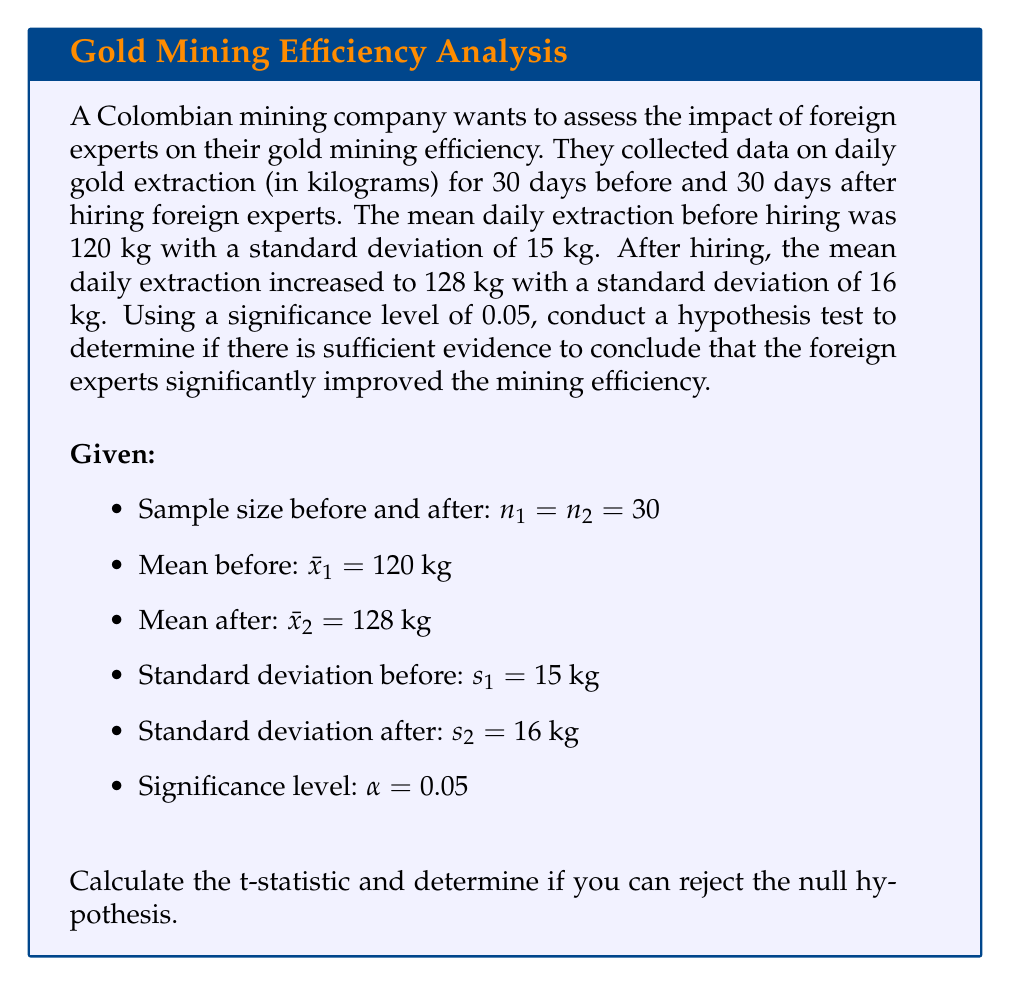Can you answer this question? To solve this problem, we'll use a two-sample t-test for independent samples with unequal variances (Welch's t-test). We'll follow these steps:

1. State the hypotheses:
   $H_0: \mu_1 = \mu_2$ (null hypothesis: no difference in means)
   $H_a: \mu_1 < \mu_2$ (alternative hypothesis: mean after is greater than mean before)

2. Calculate the degrees of freedom using the Welch–Satterthwaite equation:

   $$\nu = \frac{(\frac{s_1^2}{n_1} + \frac{s_2^2}{n_2})^2}{\frac{(s_1^2/n_1)^2}{n_1-1} + \frac{(s_2^2/n_2)^2}{n_2-1}}$$

   $$\nu = \frac{(\frac{15^2}{30} + \frac{16^2}{30})^2}{\frac{(15^2/30)^2}{29} + \frac{(16^2/30)^2}{29}} \approx 57.67$$

3. Calculate the t-statistic:

   $$t = \frac{\bar{x}_2 - \bar{x}_1}{\sqrt{\frac{s_1^2}{n_1} + \frac{s_2^2}{n_2}}}$$

   $$t = \frac{128 - 120}{\sqrt{\frac{15^2}{30} + \frac{16^2}{30}}} \approx 2.048$$

4. Find the critical t-value for a one-tailed test with $\alpha = 0.05$ and $\nu = 57.67$ (rounded to 57):
   $t_{\text{critical}} \approx 1.672$

5. Compare the calculated t-statistic to the critical t-value:
   Since $2.048 > 1.672$, we reject the null hypothesis.

6. Calculate the p-value:
   Using a t-distribution calculator with 57 degrees of freedom and t-statistic of 2.048, we get:
   $p\text{-value} \approx 0.0226$

   Since $p\text{-value} < \alpha$ (0.0226 < 0.05), we reject the null hypothesis.

Conclusion: There is sufficient evidence to conclude that the foreign experts significantly improved the mining efficiency at the 0.05 significance level.
Answer: Reject the null hypothesis. The t-statistic (2.048) is greater than the critical t-value (1.672), and the p-value (0.0226) is less than the significance level (0.05). There is sufficient evidence to conclude that the foreign experts significantly improved the mining efficiency. 